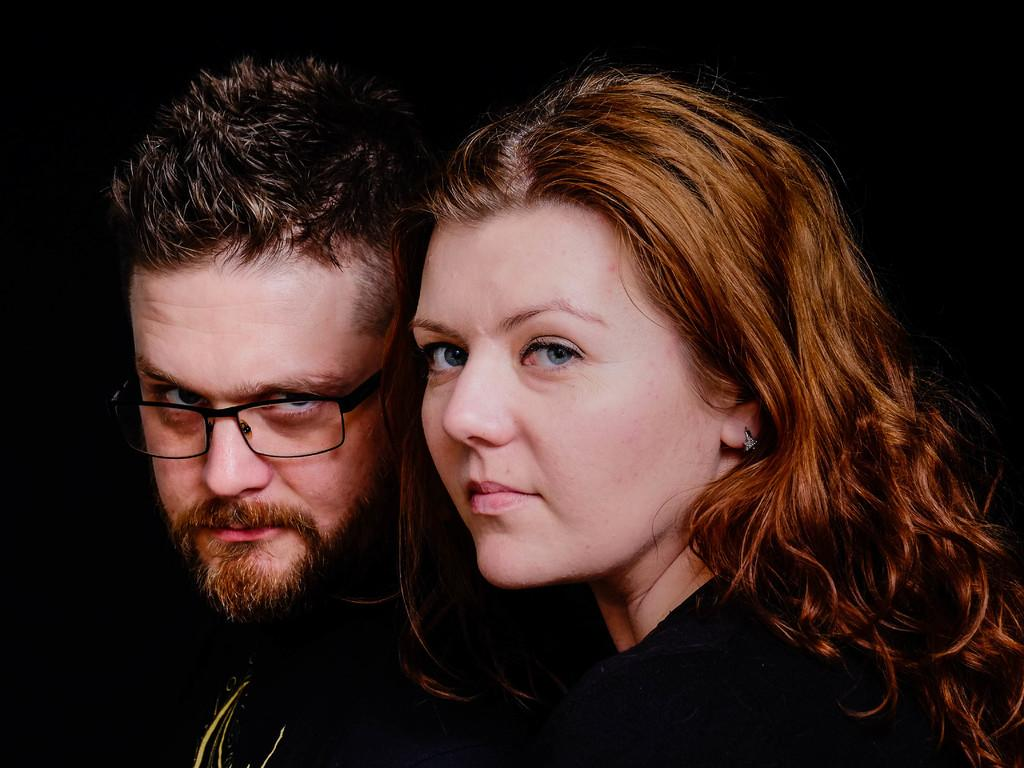Who is present in the image? There is a woman and a man in the image. What are the woman and the man doing in the image? Both the woman and the man are posing for a photo. What can be observed about the background of the image? The background of the image is dark in color. What type of nut is being shaken in the image? There is no nut or shaking action present in the image. 